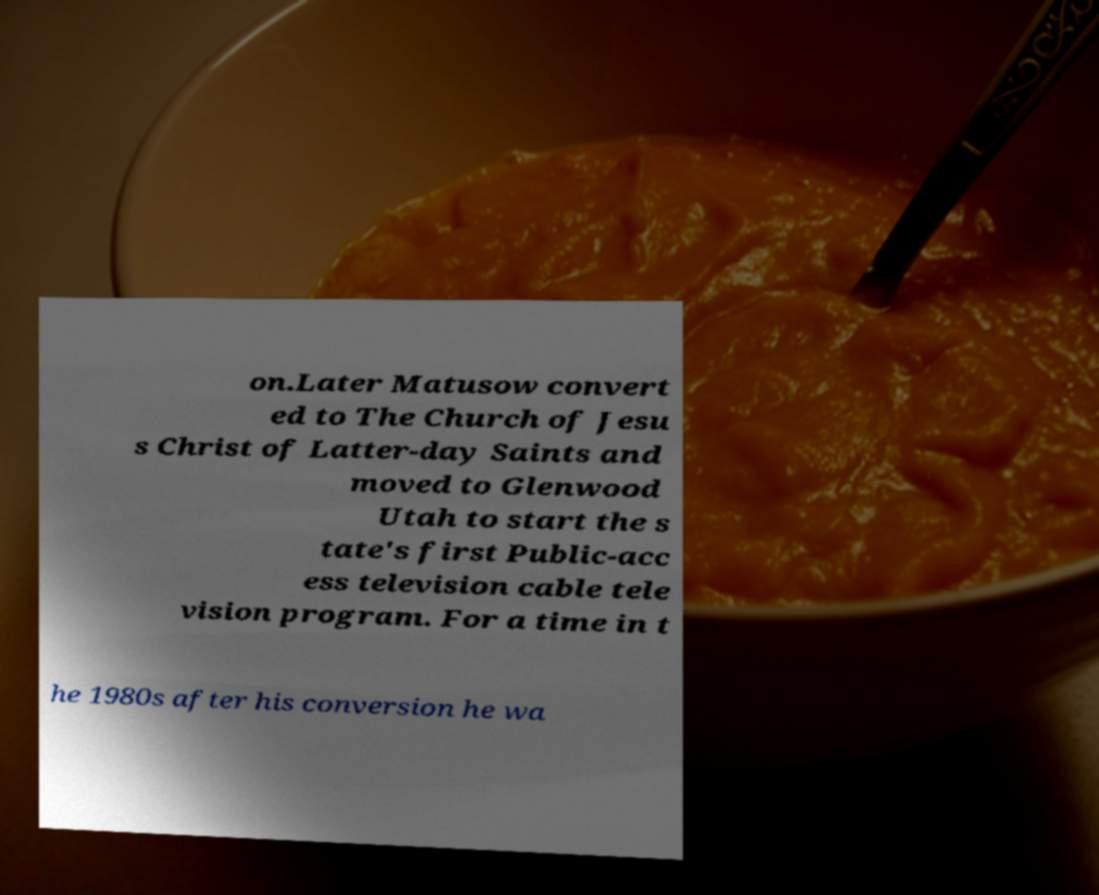Please identify and transcribe the text found in this image. on.Later Matusow convert ed to The Church of Jesu s Christ of Latter-day Saints and moved to Glenwood Utah to start the s tate's first Public-acc ess television cable tele vision program. For a time in t he 1980s after his conversion he wa 